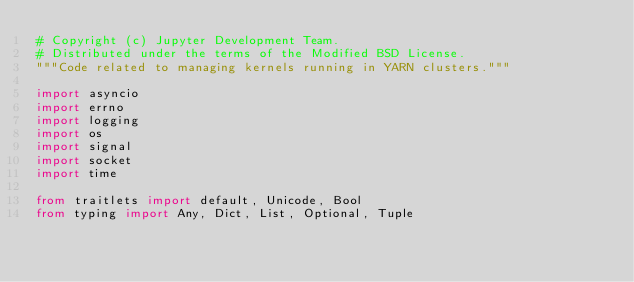<code> <loc_0><loc_0><loc_500><loc_500><_Python_># Copyright (c) Jupyter Development Team.
# Distributed under the terms of the Modified BSD License.
"""Code related to managing kernels running in YARN clusters."""

import asyncio
import errno
import logging
import os
import signal
import socket
import time

from traitlets import default, Unicode, Bool
from typing import Any, Dict, List, Optional, Tuple</code> 